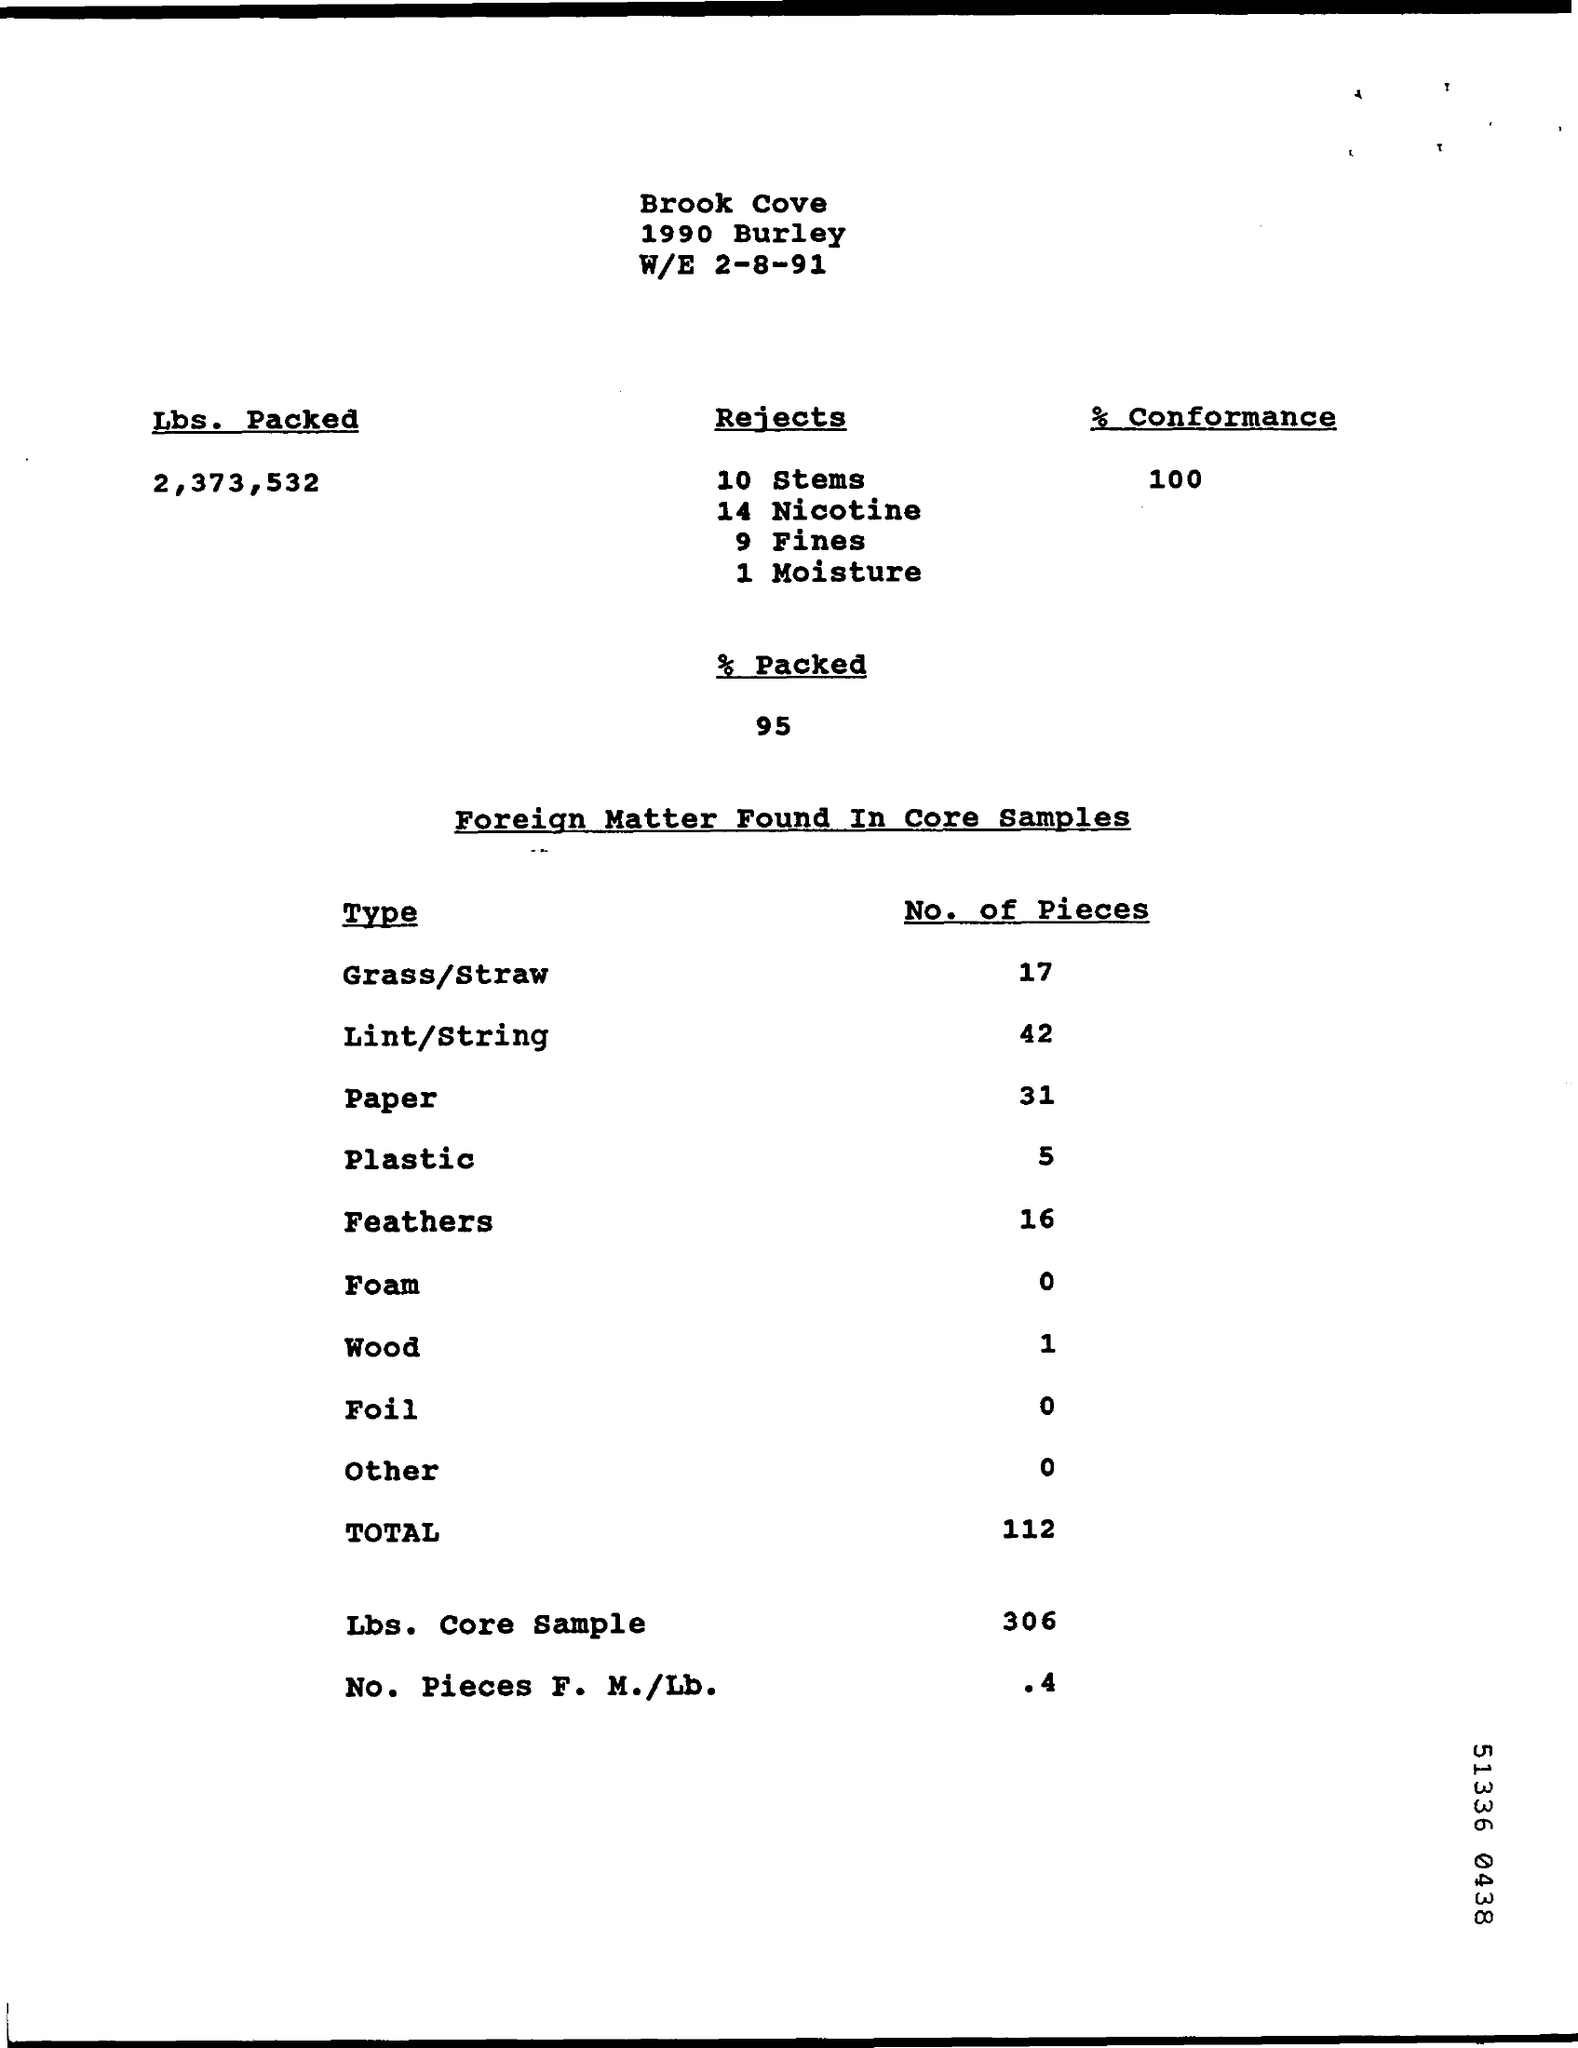Mention a couple of crucial points in this snapshot. Ninety-five percent of the package was packed. In how many instances were fines rejected? Nine times. A total of 42 pieces of lint and string were found. 